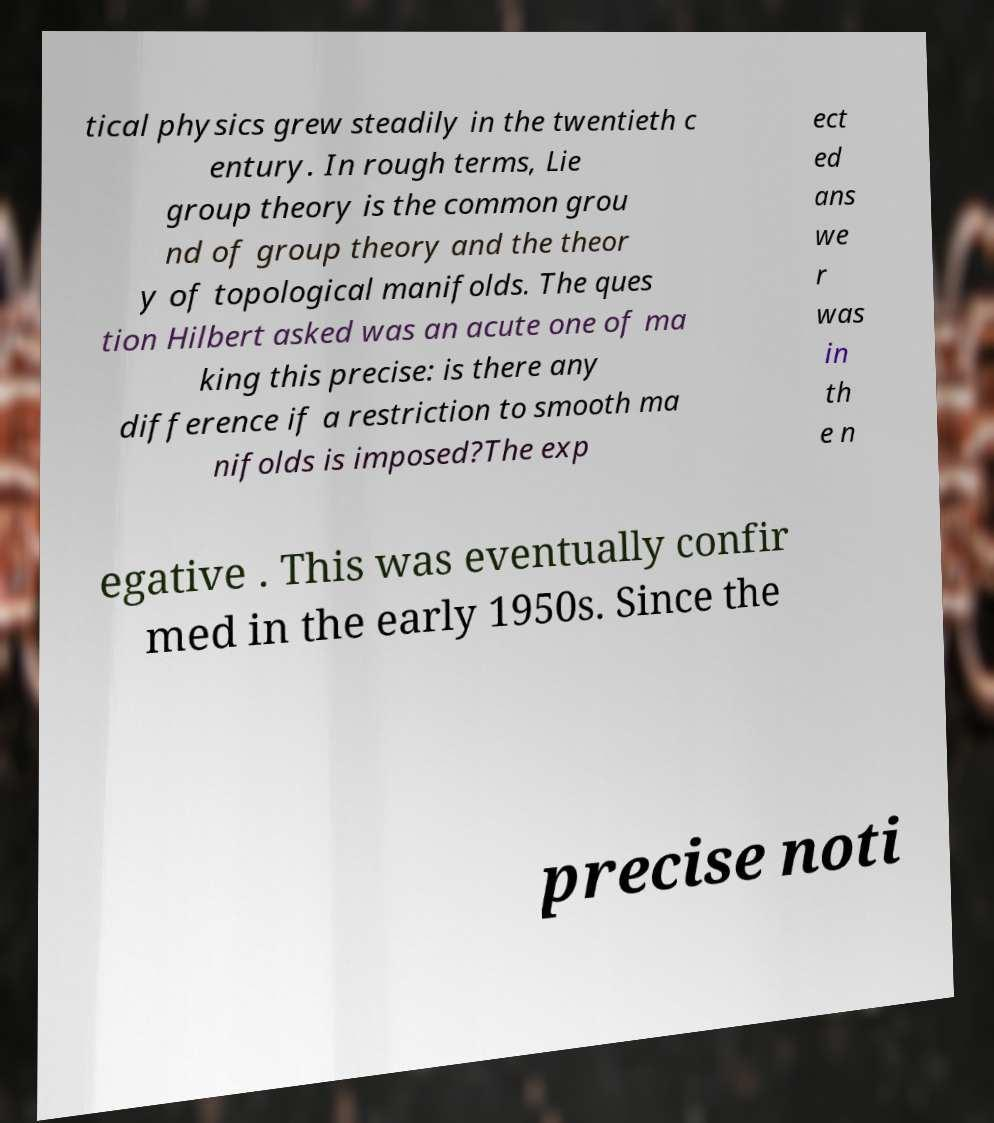There's text embedded in this image that I need extracted. Can you transcribe it verbatim? tical physics grew steadily in the twentieth c entury. In rough terms, Lie group theory is the common grou nd of group theory and the theor y of topological manifolds. The ques tion Hilbert asked was an acute one of ma king this precise: is there any difference if a restriction to smooth ma nifolds is imposed?The exp ect ed ans we r was in th e n egative . This was eventually confir med in the early 1950s. Since the precise noti 